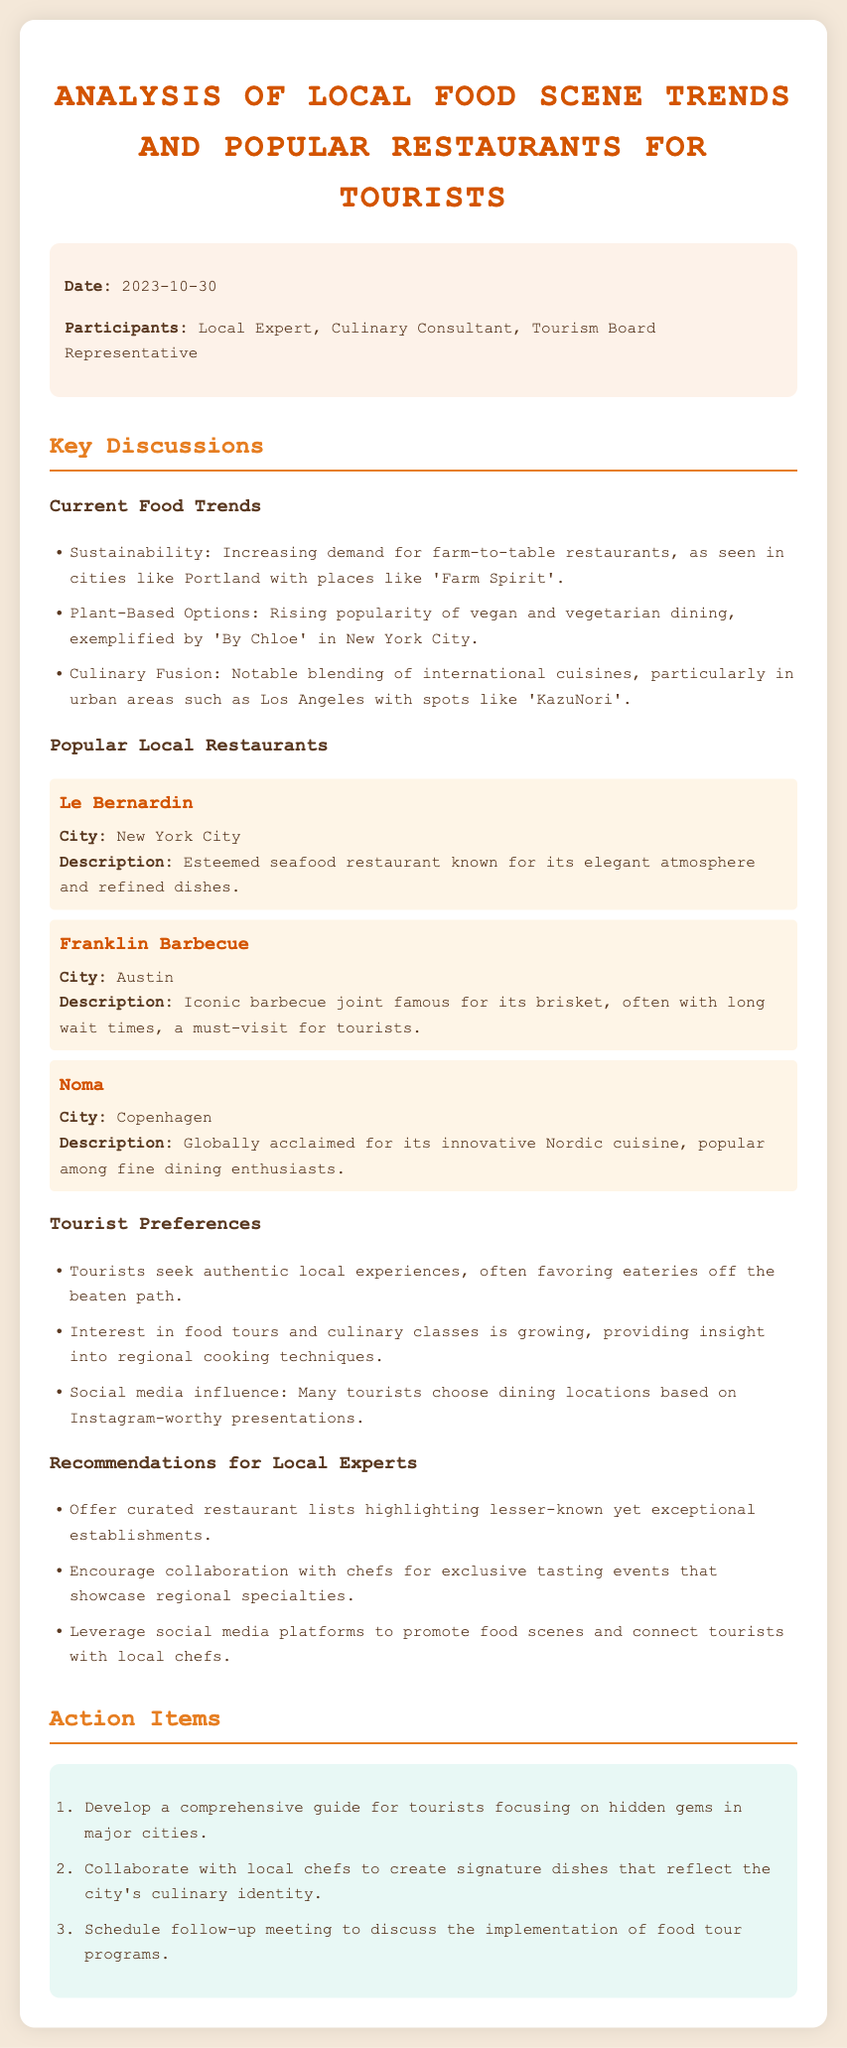what is the date of the meeting? The date of the meeting is explicitly stated in the document under the info section.
Answer: 2023-10-30 who are the participants mentioned? The participants are listed in the info section of the document.
Answer: Local Expert, Culinary Consultant, Tourism Board Representative name one current food trend discussed. The food trends are listed in the key discussions section of the document, providing several examples.
Answer: Sustainability which restaurant is known for its brisket? The description of Franklin Barbecue highlights its fame for brisket in the popular local restaurants section.
Answer: Franklin Barbecue what is one key preference of tourists mentioned? The document discusses tourist preferences in a dedicated section that mentions their dining habits.
Answer: Authentic local experiences how many action items are listed? The number of action items can be counted in the action items section.
Answer: 3 what is the role of the Culinary Consultant? The document describes the participants, including their roles during the meeting.
Answer: Culinary Consultant which city's restaurant is Noma located? The document specifies the city associated with each restaurant under the popular local restaurants section.
Answer: Copenhagen what type of restaurant is Le Bernardin? The document provides a description of Le Bernardin under the popular local restaurants section.
Answer: Seafood restaurant 